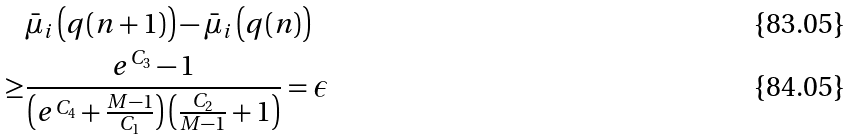Convert formula to latex. <formula><loc_0><loc_0><loc_500><loc_500>& \bar { \mu } _ { i } \left ( q ( n + 1 ) \right ) - \bar { \mu } _ { i } \left ( q ( n ) \right ) \\ \geq & \frac { e ^ { C _ { 3 } } - 1 } { \left ( e ^ { C _ { 4 } } + \frac { M - 1 } { C _ { 1 } } \right ) \left ( \frac { C _ { 2 } } { M - 1 } + 1 \right ) } = \epsilon</formula> 